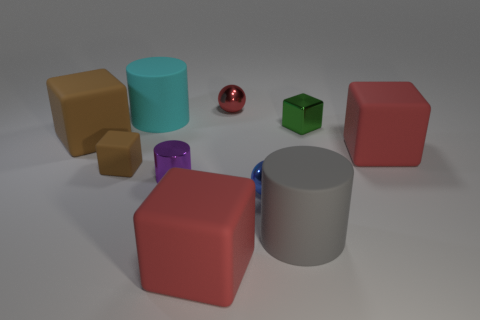Subtract all big brown blocks. How many blocks are left? 4 Subtract all green blocks. How many blocks are left? 4 Subtract all yellow blocks. Subtract all blue cylinders. How many blocks are left? 5 Subtract all cylinders. How many objects are left? 7 Add 1 gray spheres. How many gray spheres exist? 1 Subtract 0 gray cubes. How many objects are left? 10 Subtract all big red cubes. Subtract all tiny red metal balls. How many objects are left? 7 Add 2 big red cubes. How many big red cubes are left? 4 